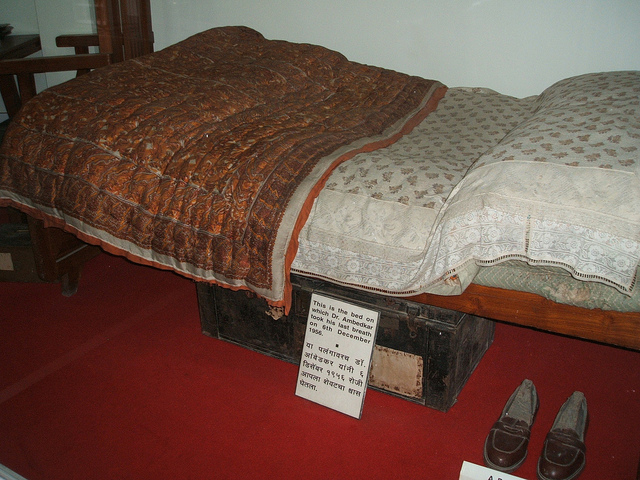<image>What happened on this bed? It is unknown what happened on the bed. The possibilities range from nothing, to sleep, to a historical event. What happened on this bed? I am not sure what happened on this bed. It can be seen that nothing happened or someone slept on it. 